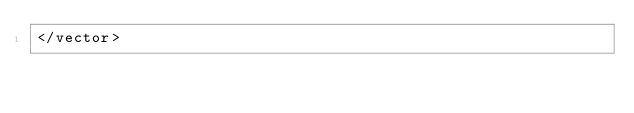<code> <loc_0><loc_0><loc_500><loc_500><_XML_></vector>
</code> 